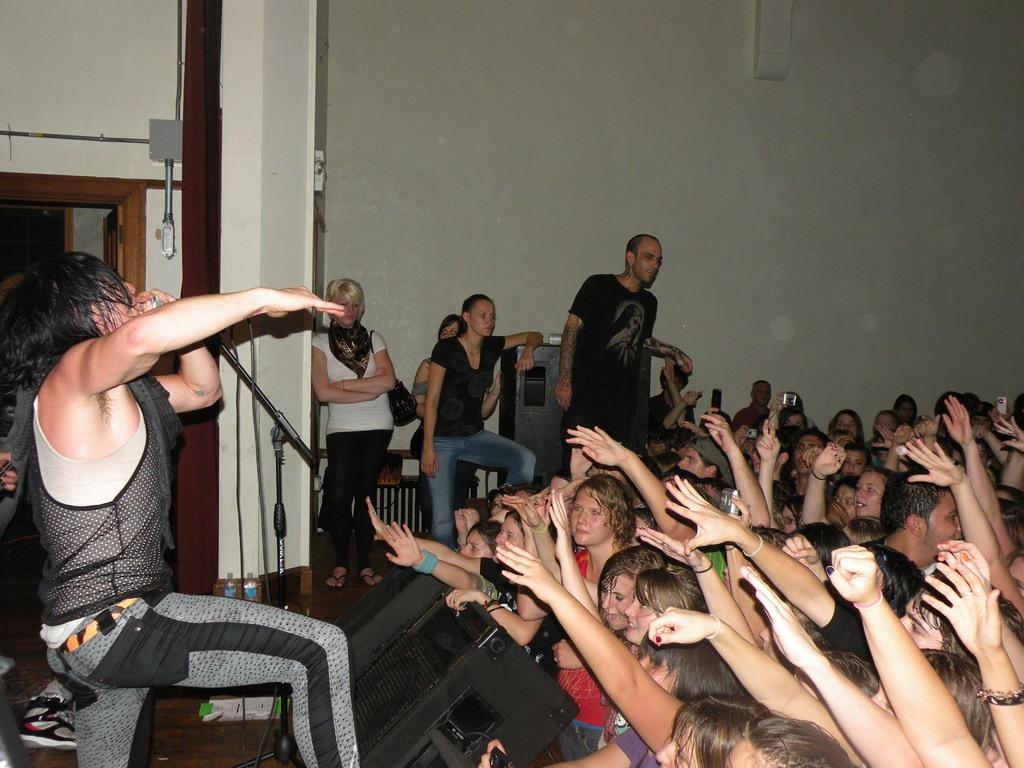Who is the main subject in the image? There is a man in the image. What is the man doing in the image? The man is standing and holding a microphone stand. Are there any other people in the image? Yes, there are other people standing in front of the man. What type of distribution is being carried out by the man with the microphone stand? There is no distribution being carried out in the image; the man is simply holding a microphone stand. 